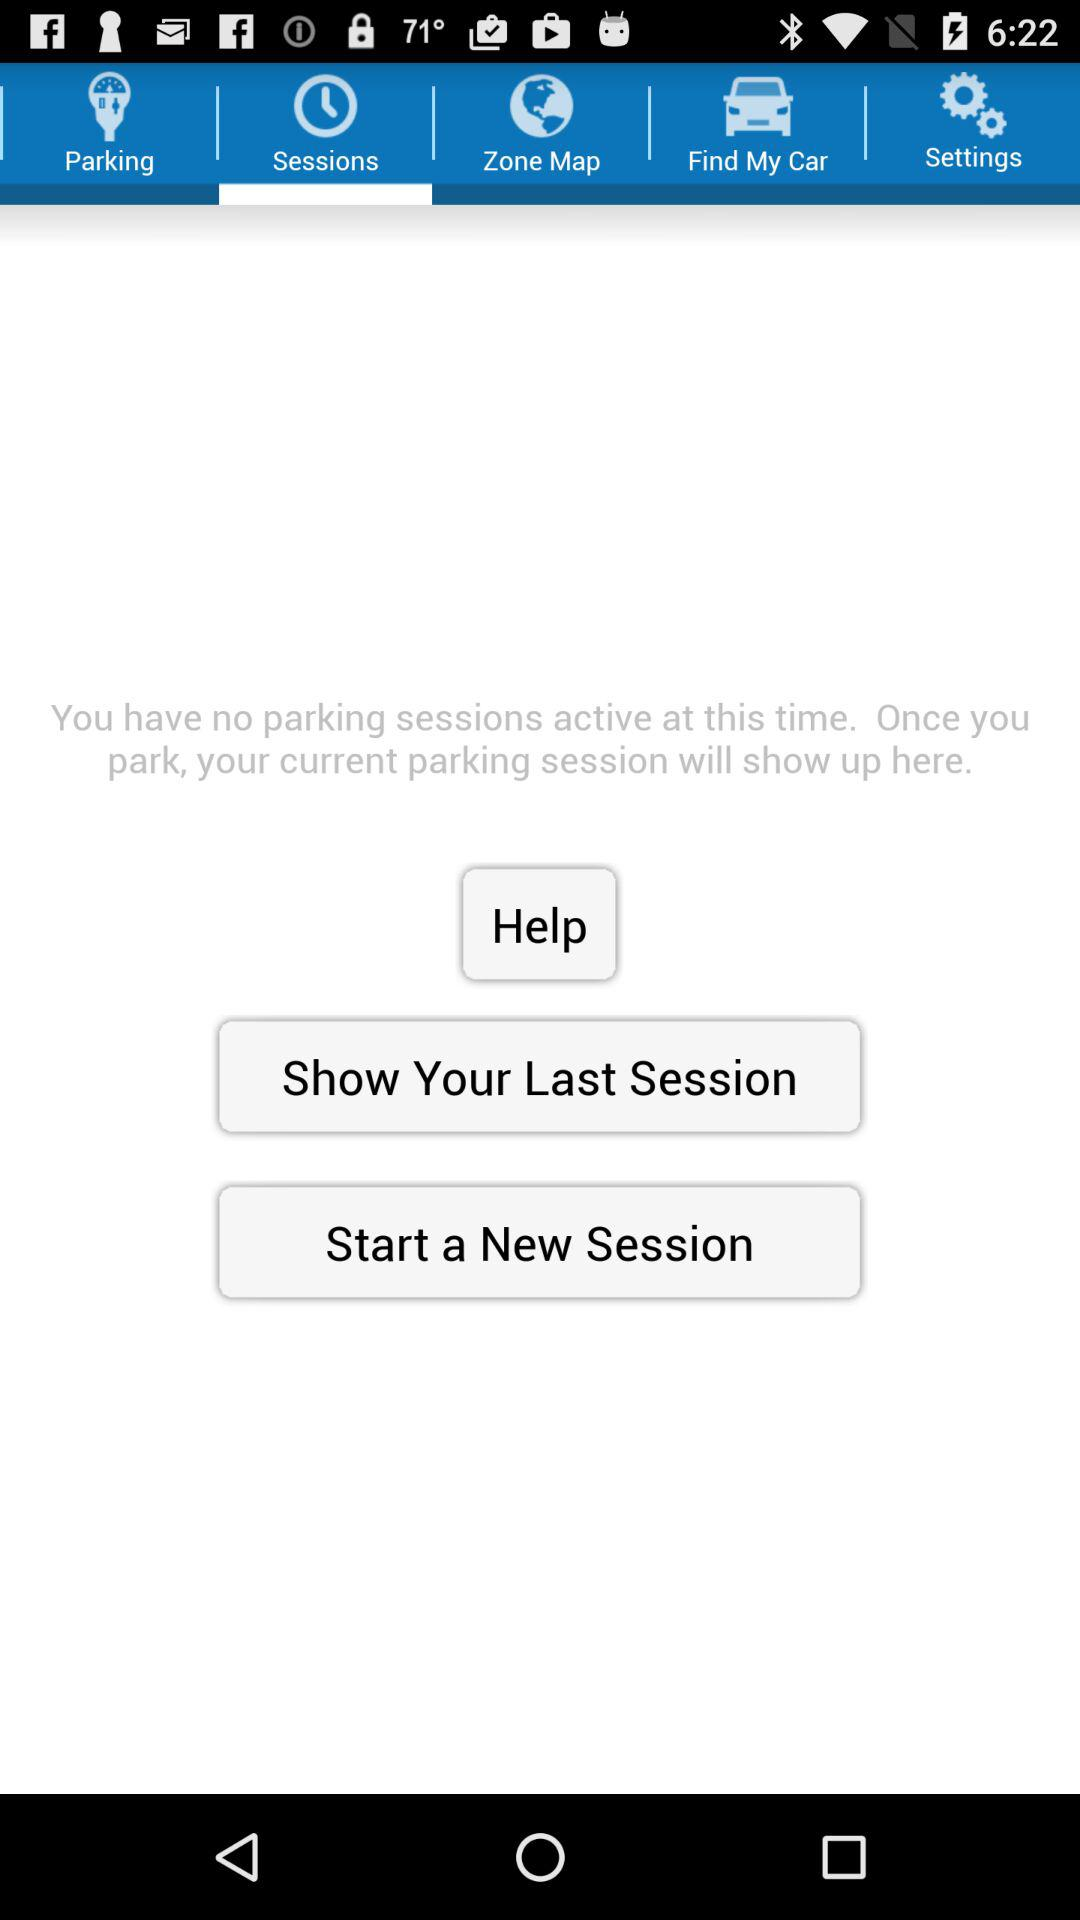How many sessions do I currently have?
Answer the question using a single word or phrase. 0 